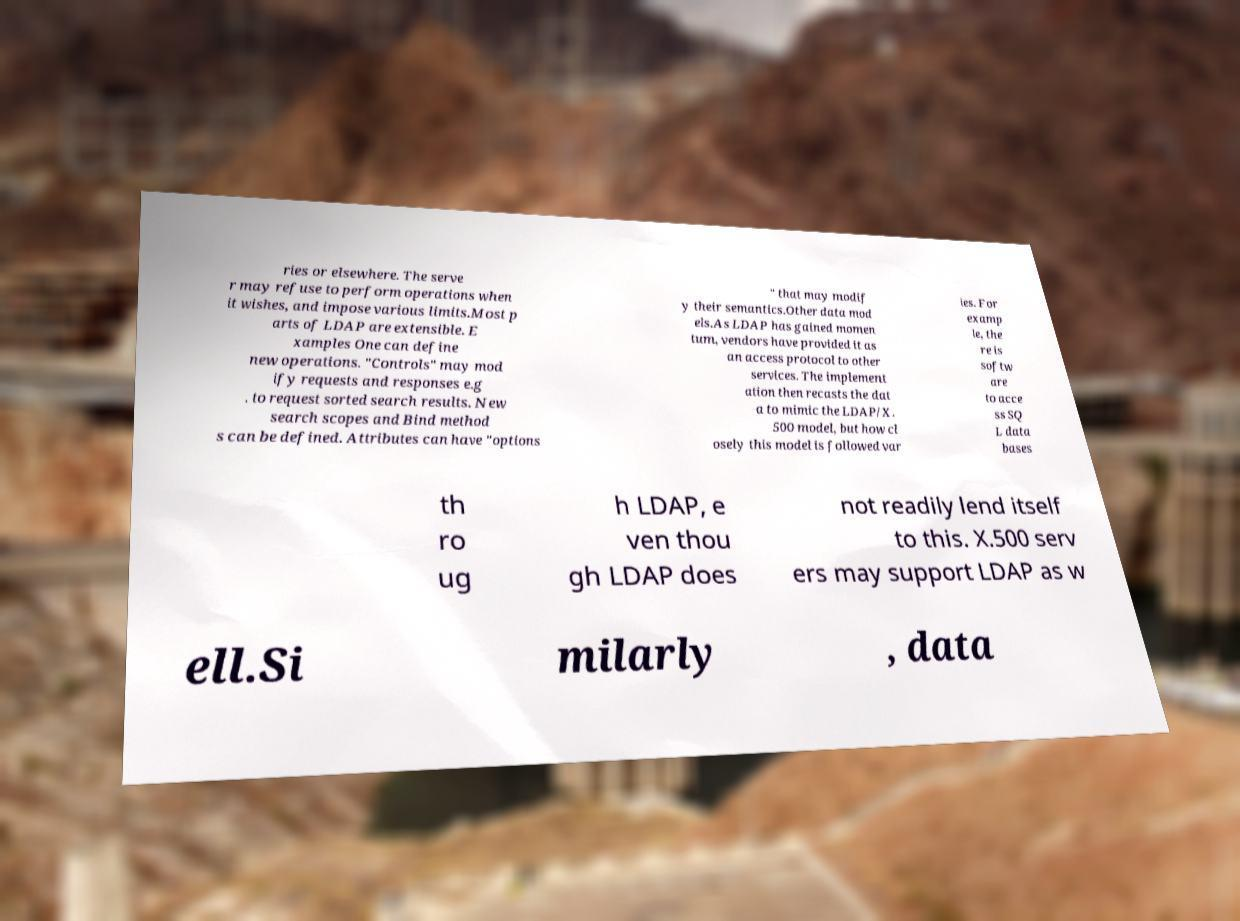For documentation purposes, I need the text within this image transcribed. Could you provide that? ries or elsewhere. The serve r may refuse to perform operations when it wishes, and impose various limits.Most p arts of LDAP are extensible. E xamples One can define new operations. "Controls" may mod ify requests and responses e.g . to request sorted search results. New search scopes and Bind method s can be defined. Attributes can have "options " that may modif y their semantics.Other data mod els.As LDAP has gained momen tum, vendors have provided it as an access protocol to other services. The implement ation then recasts the dat a to mimic the LDAP/X. 500 model, but how cl osely this model is followed var ies. For examp le, the re is softw are to acce ss SQ L data bases th ro ug h LDAP, e ven thou gh LDAP does not readily lend itself to this. X.500 serv ers may support LDAP as w ell.Si milarly , data 